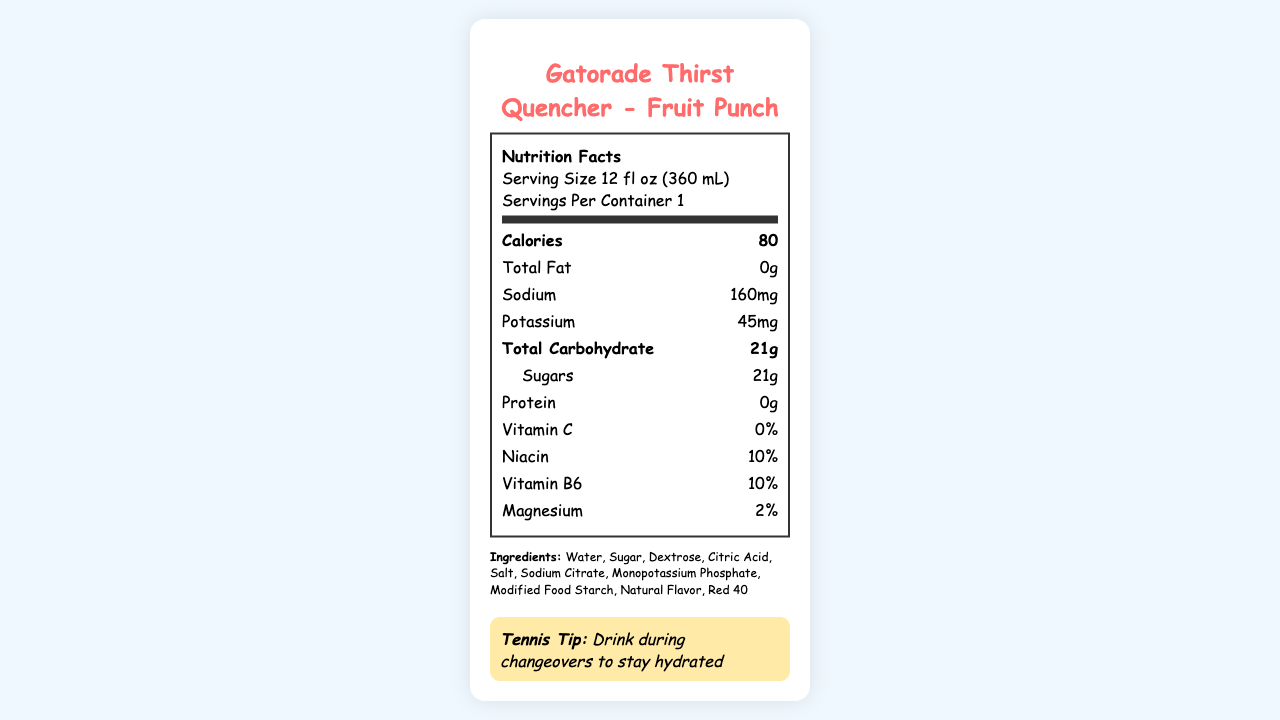what is the serving size for Gatorade Thirst Quencher? The serving size is explicitly mentioned in the document as "12 fl oz (360 mL)".
Answer: 12 fl oz (360 mL) how many calories are in one serving of Gatorade Thirst Quencher? The document states that there are 80 calories per serving.
Answer: 80 how much sodium does a serving contain? The sodium content per serving is listed as 160mg in the nutrition facts.
Answer: 160mg what is the main flavor of this Gatorade Thirst Quencher? The main flavor is given as "Fruit Punch" in the document.
Answer: Fruit Punch does Gatorade Thirst Quencher contain any protein? The protein content is listed as 0g, meaning it contains no protein.
Answer: No which vitamin is not present in Gatorade Thirst Quencher? A. Vitamin C B. Niacin C. Vitamin B6 D. Magnesium The document shows that Vitamin C is listed at 0%, while the other nutrients have a percentage value.
Answer: A. Vitamin C how should you ideally consume this drink? A. At room temperature B. Ice cold C. Warm D. Hot The consumer tip section mentions that it tastes best when ice cold.
Answer: B. Ice cold what is the slogan for Gatorade Thirst Quencher? The slogan "Is it in you?" is mentioned in the document.
Answer: Is it in you? is this drink endorsed by a tennis player? The endorsement by Serena Williams is mentioned in the document.
Answer: Yes describe the entire document. The document provides detailed nutritional information along with endorsements, slogan, and usage tips for the sports drink.
Answer: The document is a nutrition facts label for the Gatorade Thirst Quencher, Fruit Punch flavor, endorsed by Serena Williams with the slogan "Is it in you?". It includes serving size, calories, and other nutritional details, such as total fat, sodium, potassium, carbohydrates, sugars, and protein. It lists vitamins and minerals, ingredients, a fun fact about its bright colors, and a consumer tip suggesting it tastes best when ice cold. who is the manufacturer of Gatorade Thirst Quencher? There is no information in the document about the manufacturer.
Answer: Not enough information 